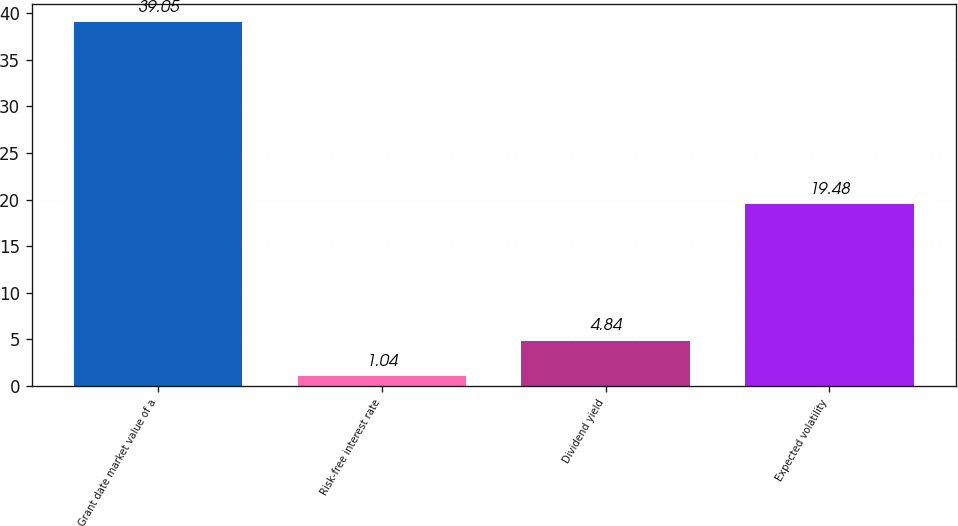<chart> <loc_0><loc_0><loc_500><loc_500><bar_chart><fcel>Grant date market value of a<fcel>Risk-free interest rate<fcel>Dividend yield<fcel>Expected volatility<nl><fcel>39.05<fcel>1.04<fcel>4.84<fcel>19.48<nl></chart> 